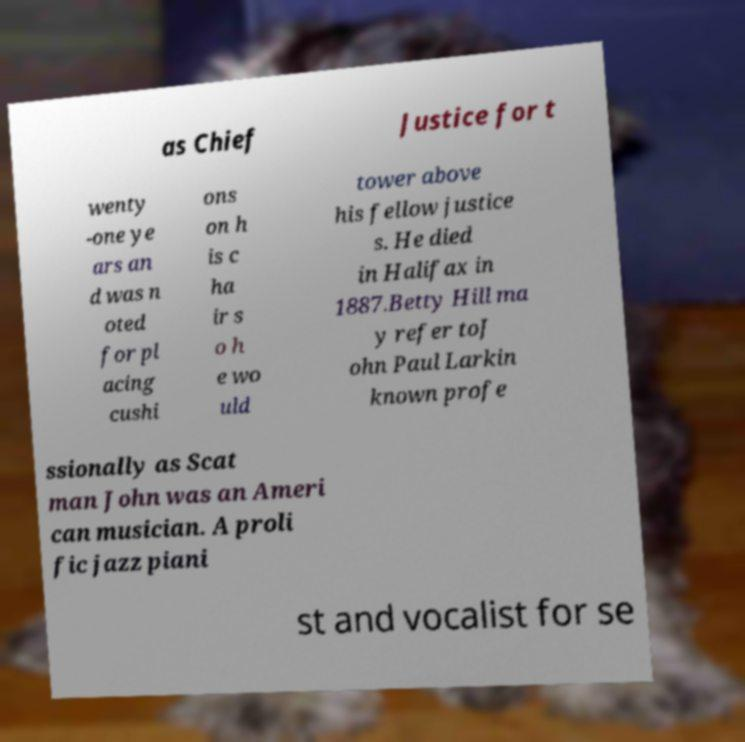Could you extract and type out the text from this image? as Chief Justice for t wenty -one ye ars an d was n oted for pl acing cushi ons on h is c ha ir s o h e wo uld tower above his fellow justice s. He died in Halifax in 1887.Betty Hill ma y refer toJ ohn Paul Larkin known profe ssionally as Scat man John was an Ameri can musician. A proli fic jazz piani st and vocalist for se 